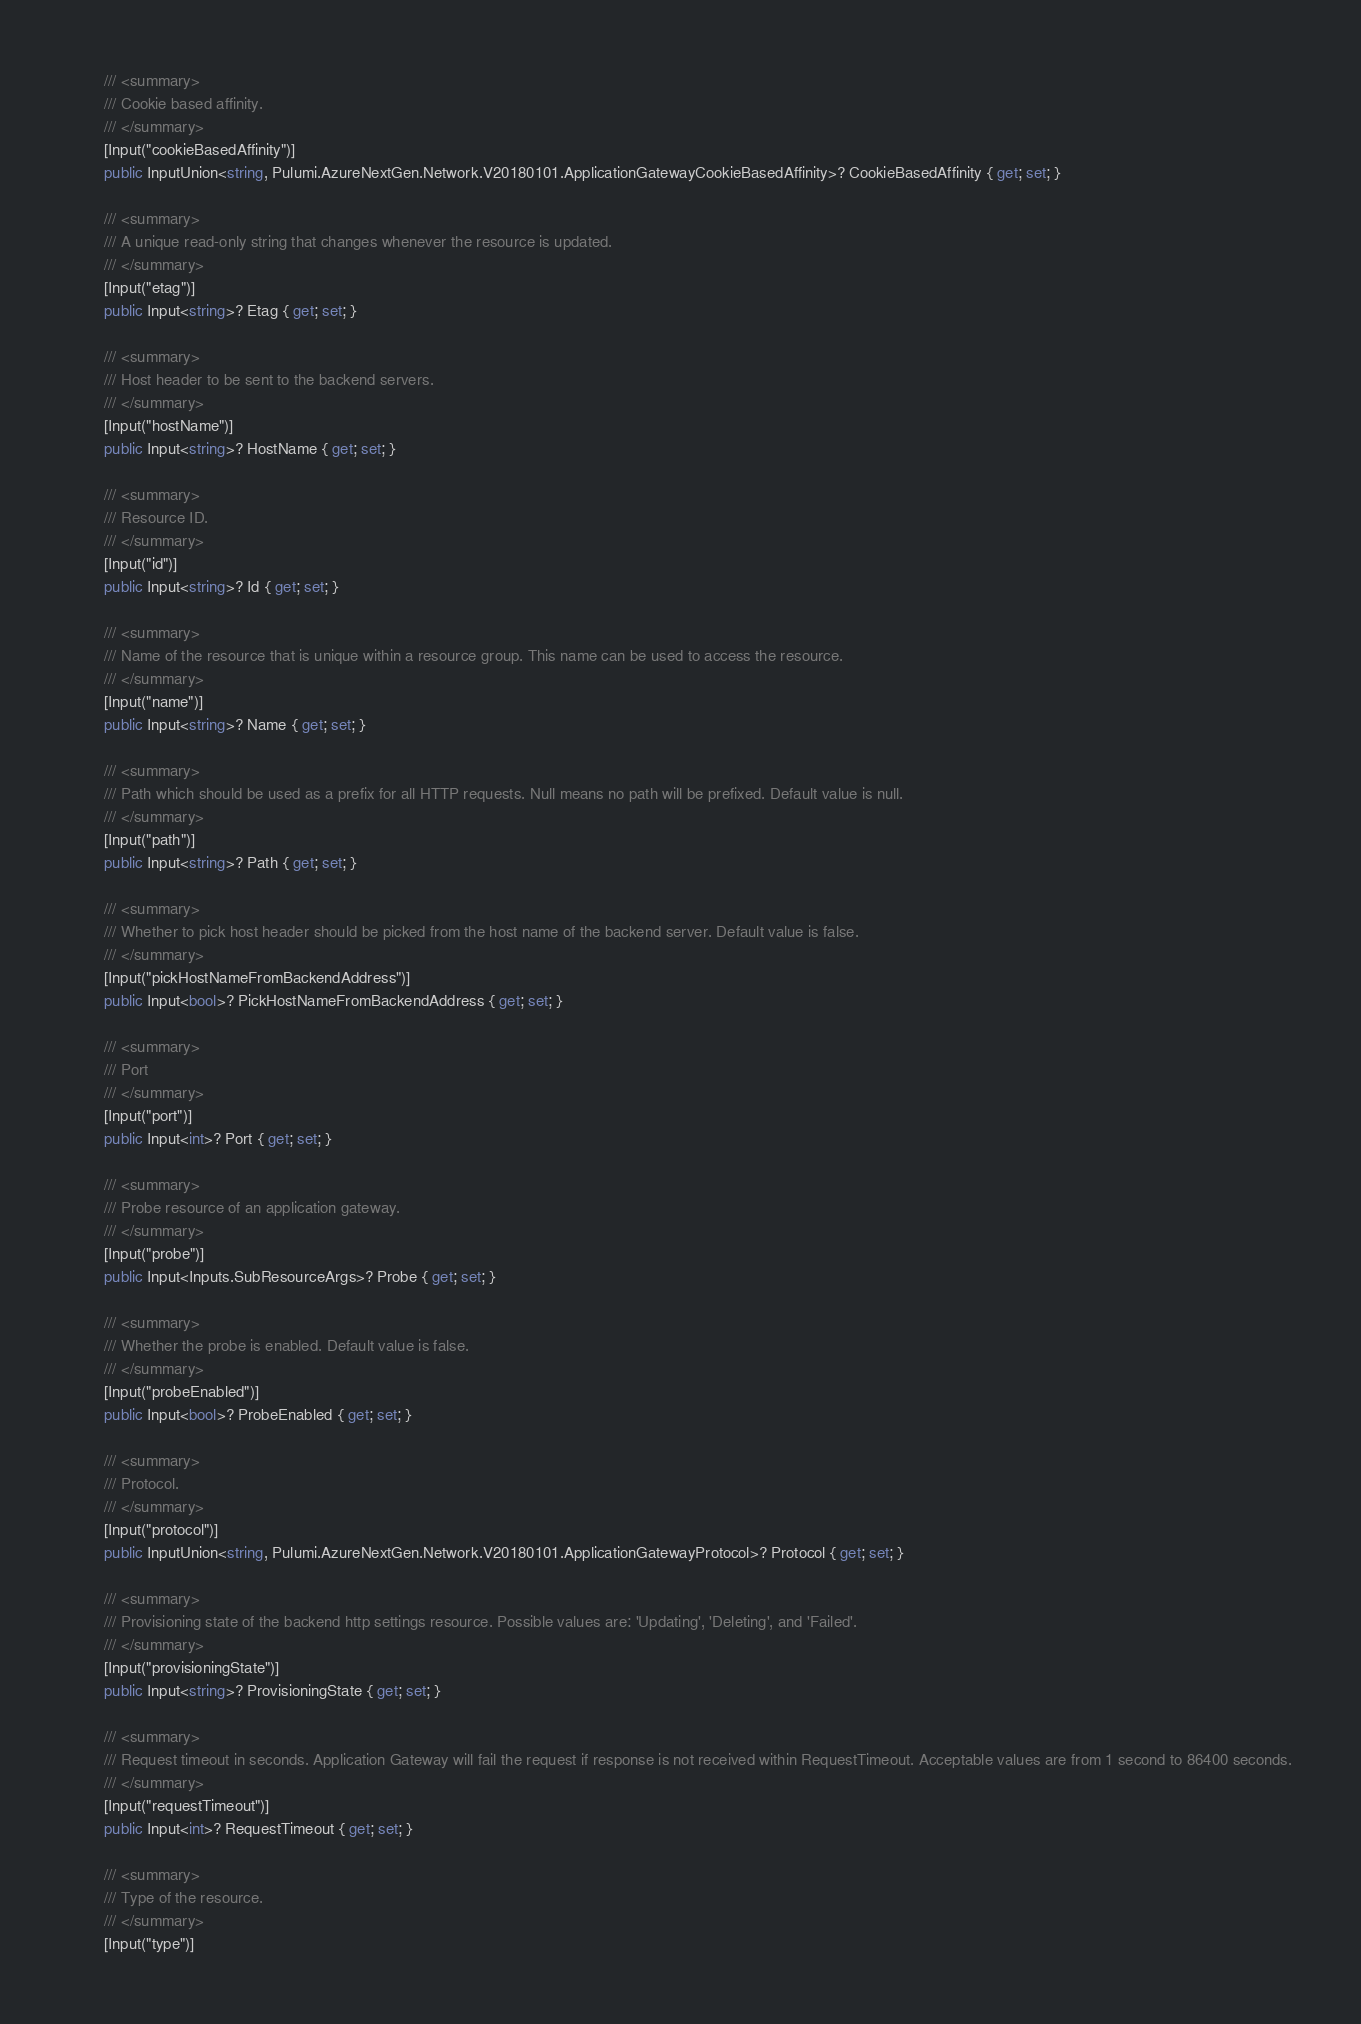Convert code to text. <code><loc_0><loc_0><loc_500><loc_500><_C#_>
        /// <summary>
        /// Cookie based affinity.
        /// </summary>
        [Input("cookieBasedAffinity")]
        public InputUnion<string, Pulumi.AzureNextGen.Network.V20180101.ApplicationGatewayCookieBasedAffinity>? CookieBasedAffinity { get; set; }

        /// <summary>
        /// A unique read-only string that changes whenever the resource is updated.
        /// </summary>
        [Input("etag")]
        public Input<string>? Etag { get; set; }

        /// <summary>
        /// Host header to be sent to the backend servers.
        /// </summary>
        [Input("hostName")]
        public Input<string>? HostName { get; set; }

        /// <summary>
        /// Resource ID.
        /// </summary>
        [Input("id")]
        public Input<string>? Id { get; set; }

        /// <summary>
        /// Name of the resource that is unique within a resource group. This name can be used to access the resource.
        /// </summary>
        [Input("name")]
        public Input<string>? Name { get; set; }

        /// <summary>
        /// Path which should be used as a prefix for all HTTP requests. Null means no path will be prefixed. Default value is null.
        /// </summary>
        [Input("path")]
        public Input<string>? Path { get; set; }

        /// <summary>
        /// Whether to pick host header should be picked from the host name of the backend server. Default value is false.
        /// </summary>
        [Input("pickHostNameFromBackendAddress")]
        public Input<bool>? PickHostNameFromBackendAddress { get; set; }

        /// <summary>
        /// Port
        /// </summary>
        [Input("port")]
        public Input<int>? Port { get; set; }

        /// <summary>
        /// Probe resource of an application gateway.
        /// </summary>
        [Input("probe")]
        public Input<Inputs.SubResourceArgs>? Probe { get; set; }

        /// <summary>
        /// Whether the probe is enabled. Default value is false.
        /// </summary>
        [Input("probeEnabled")]
        public Input<bool>? ProbeEnabled { get; set; }

        /// <summary>
        /// Protocol.
        /// </summary>
        [Input("protocol")]
        public InputUnion<string, Pulumi.AzureNextGen.Network.V20180101.ApplicationGatewayProtocol>? Protocol { get; set; }

        /// <summary>
        /// Provisioning state of the backend http settings resource. Possible values are: 'Updating', 'Deleting', and 'Failed'.
        /// </summary>
        [Input("provisioningState")]
        public Input<string>? ProvisioningState { get; set; }

        /// <summary>
        /// Request timeout in seconds. Application Gateway will fail the request if response is not received within RequestTimeout. Acceptable values are from 1 second to 86400 seconds.
        /// </summary>
        [Input("requestTimeout")]
        public Input<int>? RequestTimeout { get; set; }

        /// <summary>
        /// Type of the resource.
        /// </summary>
        [Input("type")]</code> 